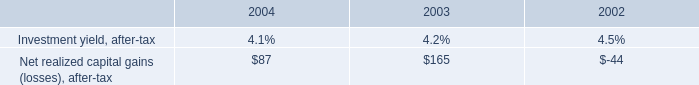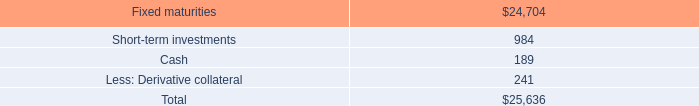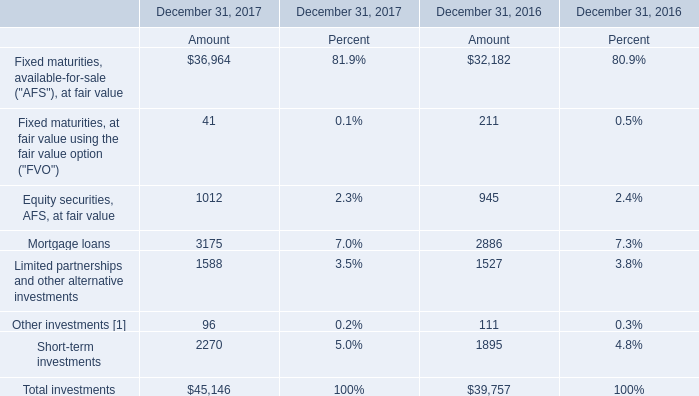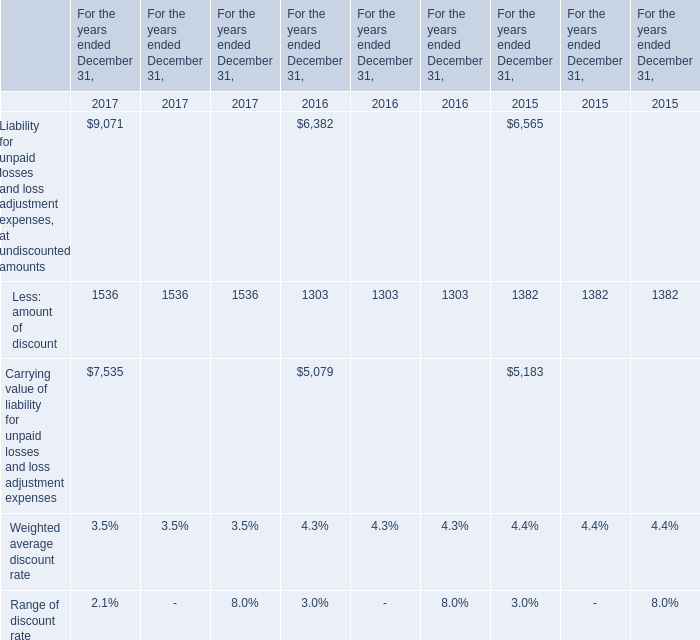What is the sum of the total investment in the years where Mortgage loans is greater than 3000? 
Computations: ((((((32182 + 211) + 945) + 2886) + 1527) + 111) + 1895)
Answer: 39757.0. 